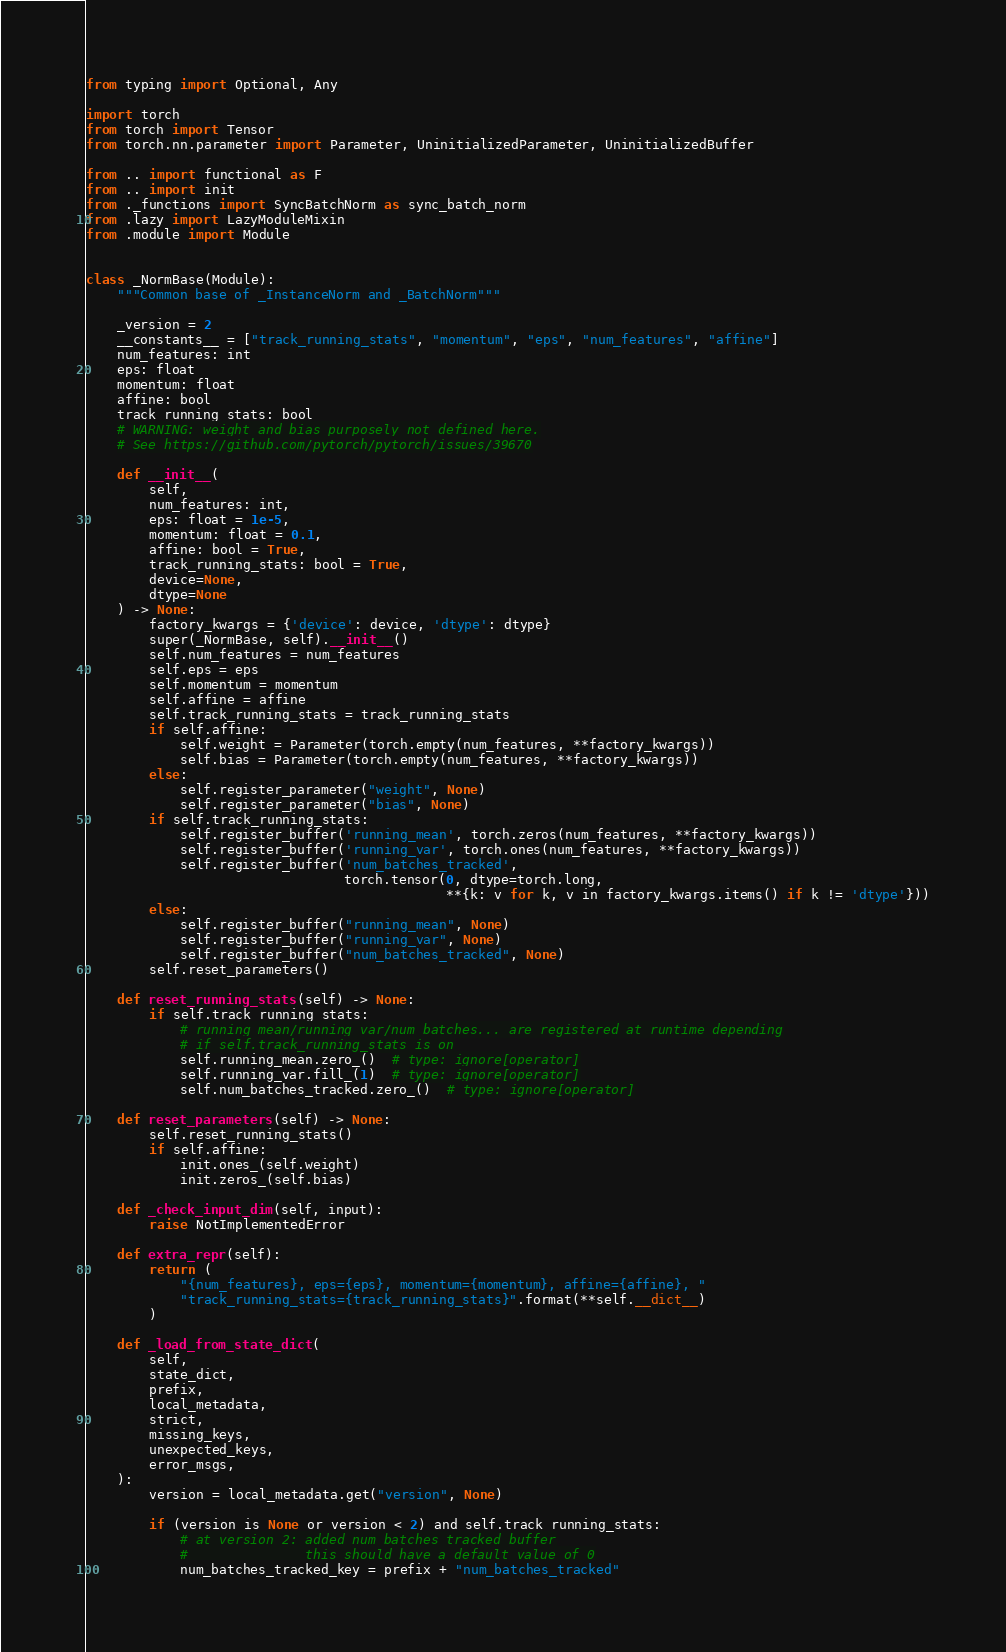<code> <loc_0><loc_0><loc_500><loc_500><_Python_>from typing import Optional, Any

import torch
from torch import Tensor
from torch.nn.parameter import Parameter, UninitializedParameter, UninitializedBuffer

from .. import functional as F
from .. import init
from ._functions import SyncBatchNorm as sync_batch_norm
from .lazy import LazyModuleMixin
from .module import Module


class _NormBase(Module):
    """Common base of _InstanceNorm and _BatchNorm"""

    _version = 2
    __constants__ = ["track_running_stats", "momentum", "eps", "num_features", "affine"]
    num_features: int
    eps: float
    momentum: float
    affine: bool
    track_running_stats: bool
    # WARNING: weight and bias purposely not defined here.
    # See https://github.com/pytorch/pytorch/issues/39670

    def __init__(
        self,
        num_features: int,
        eps: float = 1e-5,
        momentum: float = 0.1,
        affine: bool = True,
        track_running_stats: bool = True,
        device=None,
        dtype=None
    ) -> None:
        factory_kwargs = {'device': device, 'dtype': dtype}
        super(_NormBase, self).__init__()
        self.num_features = num_features
        self.eps = eps
        self.momentum = momentum
        self.affine = affine
        self.track_running_stats = track_running_stats
        if self.affine:
            self.weight = Parameter(torch.empty(num_features, **factory_kwargs))
            self.bias = Parameter(torch.empty(num_features, **factory_kwargs))
        else:
            self.register_parameter("weight", None)
            self.register_parameter("bias", None)
        if self.track_running_stats:
            self.register_buffer('running_mean', torch.zeros(num_features, **factory_kwargs))
            self.register_buffer('running_var', torch.ones(num_features, **factory_kwargs))
            self.register_buffer('num_batches_tracked',
                                 torch.tensor(0, dtype=torch.long,
                                              **{k: v for k, v in factory_kwargs.items() if k != 'dtype'}))
        else:
            self.register_buffer("running_mean", None)
            self.register_buffer("running_var", None)
            self.register_buffer("num_batches_tracked", None)
        self.reset_parameters()

    def reset_running_stats(self) -> None:
        if self.track_running_stats:
            # running_mean/running_var/num_batches... are registered at runtime depending
            # if self.track_running_stats is on
            self.running_mean.zero_()  # type: ignore[operator]
            self.running_var.fill_(1)  # type: ignore[operator]
            self.num_batches_tracked.zero_()  # type: ignore[operator]

    def reset_parameters(self) -> None:
        self.reset_running_stats()
        if self.affine:
            init.ones_(self.weight)
            init.zeros_(self.bias)

    def _check_input_dim(self, input):
        raise NotImplementedError

    def extra_repr(self):
        return (
            "{num_features}, eps={eps}, momentum={momentum}, affine={affine}, "
            "track_running_stats={track_running_stats}".format(**self.__dict__)
        )

    def _load_from_state_dict(
        self,
        state_dict,
        prefix,
        local_metadata,
        strict,
        missing_keys,
        unexpected_keys,
        error_msgs,
    ):
        version = local_metadata.get("version", None)

        if (version is None or version < 2) and self.track_running_stats:
            # at version 2: added num_batches_tracked buffer
            #               this should have a default value of 0
            num_batches_tracked_key = prefix + "num_batches_tracked"</code> 